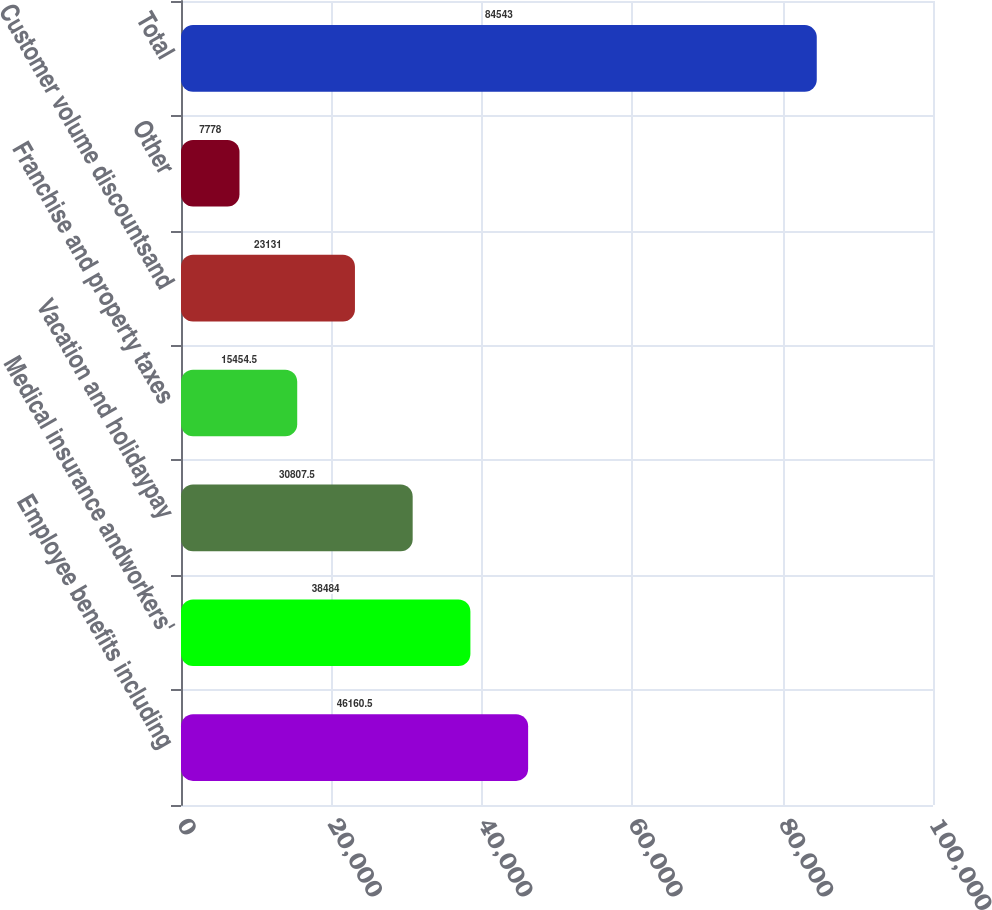Convert chart to OTSL. <chart><loc_0><loc_0><loc_500><loc_500><bar_chart><fcel>Employee benefits including<fcel>Medical insurance andworkers'<fcel>Vacation and holidaypay<fcel>Franchise and property taxes<fcel>Customer volume discountsand<fcel>Other<fcel>Total<nl><fcel>46160.5<fcel>38484<fcel>30807.5<fcel>15454.5<fcel>23131<fcel>7778<fcel>84543<nl></chart> 